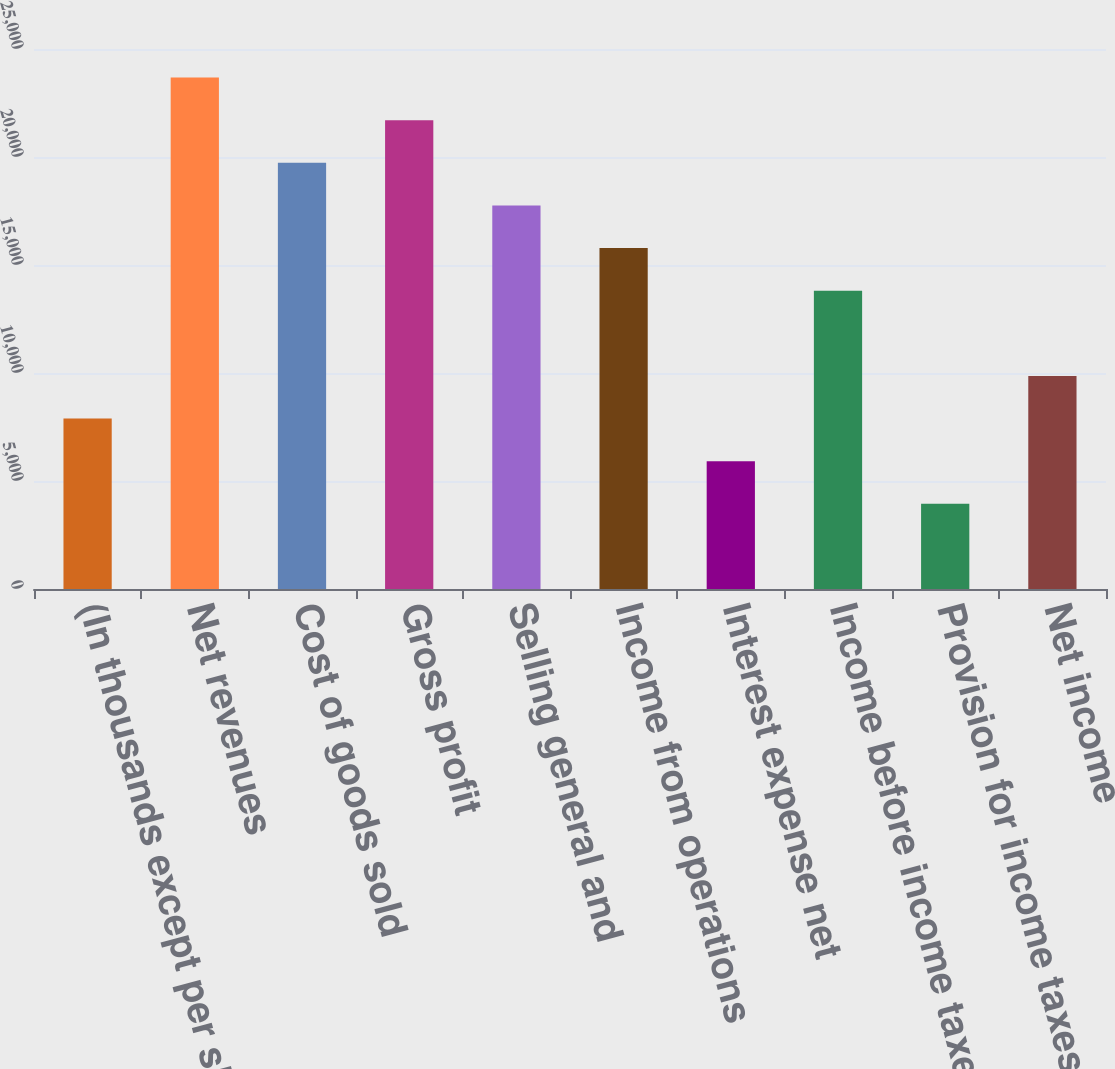Convert chart. <chart><loc_0><loc_0><loc_500><loc_500><bar_chart><fcel>(In thousands except per share<fcel>Net revenues<fcel>Cost of goods sold<fcel>Gross profit<fcel>Selling general and<fcel>Income from operations<fcel>Interest expense net<fcel>Income before income taxes<fcel>Provision for income taxes(1)<fcel>Net income<nl><fcel>7892.88<fcel>23678.4<fcel>19732<fcel>21705.2<fcel>17758.8<fcel>15785.6<fcel>5919.69<fcel>13812.5<fcel>3946.5<fcel>9866.07<nl></chart> 